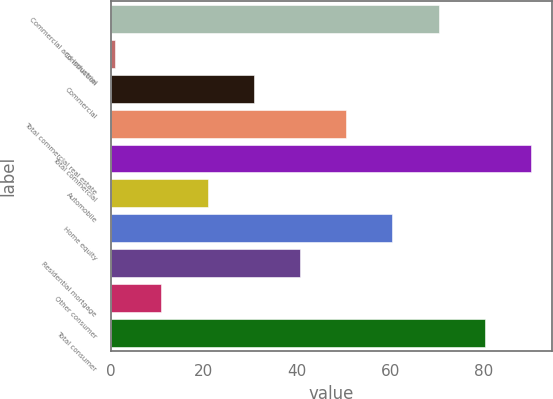Convert chart to OTSL. <chart><loc_0><loc_0><loc_500><loc_500><bar_chart><fcel>Commercial and industrial<fcel>Construction<fcel>Commercial<fcel>Total commercial real estate<fcel>Total commercial<fcel>Automobile<fcel>Home equity<fcel>Residential mortgage<fcel>Other consumer<fcel>Total consumer<nl><fcel>70.3<fcel>1<fcel>30.7<fcel>50.5<fcel>90.1<fcel>20.8<fcel>60.4<fcel>40.6<fcel>10.9<fcel>80.2<nl></chart> 